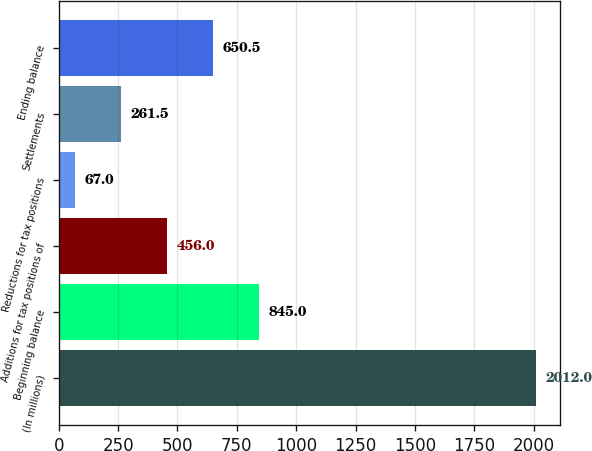<chart> <loc_0><loc_0><loc_500><loc_500><bar_chart><fcel>(In millions)<fcel>Beginning balance<fcel>Additions for tax positions of<fcel>Reductions for tax positions<fcel>Settlements<fcel>Ending balance<nl><fcel>2012<fcel>845<fcel>456<fcel>67<fcel>261.5<fcel>650.5<nl></chart> 